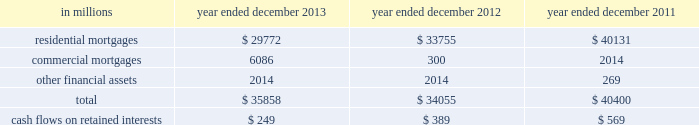Notes to consolidated financial statements note 10 .
Securitization activities the firm securitizes residential and commercial mortgages , corporate bonds , loans and other types of financial assets by selling these assets to securitization vehicles ( e.g. , trusts , corporate entities and limited liability companies ) or through a resecuritization .
The firm acts as underwriter of the beneficial interests that are sold to investors .
The firm 2019s residential mortgage securitizations are substantially all in connection with government agency securitizations .
Beneficial interests issued by securitization entities are debt or equity securities that give the investors rights to receive all or portions of specified cash inflows to a securitization vehicle and include senior and subordinated interests in principal , interest and/or other cash inflows .
The proceeds from the sale of beneficial interests are used to pay the transferor for the financial assets sold to the securitization vehicle or to purchase securities which serve as collateral .
The firm accounts for a securitization as a sale when it has relinquished control over the transferred assets .
Prior to securitization , the firm accounts for assets pending transfer at fair value and therefore does not typically recognize significant gains or losses upon the transfer of assets .
Net revenues from underwriting activities are recognized in connection with the sales of the underlying beneficial interests to investors .
For transfers of assets that are not accounted for as sales , the assets remain in 201cfinancial instruments owned , at fair value 201d and the transfer is accounted for as a collateralized financing , with the related interest expense recognized over the life of the transaction .
See notes 9 and 23 for further information about collateralized financings and interest expense , respectively .
The firm generally receives cash in exchange for the transferred assets but may also have continuing involvement with transferred assets , including ownership of beneficial interests in securitized financial assets , primarily in the form of senior or subordinated securities .
The firm may also purchase senior or subordinated securities issued by securitization vehicles ( which are typically vies ) in connection with secondary market-making activities .
The primary risks included in beneficial interests and other interests from the firm 2019s continuing involvement with securitization vehicles are the performance of the underlying collateral , the position of the firm 2019s investment in the capital structure of the securitization vehicle and the market yield for the security .
These interests are accounted for at fair value and are included in 201cfinancial instruments owned , at fair value 201d and are generally classified in level 2 of the fair value hierarchy .
See notes 5 through 8 for further information about fair value measurements .
The table below presents the amount of financial assets securitized and the cash flows received on retained interests in securitization entities in which the firm had continuing involvement. .
Goldman sachs 2013 annual report 165 .
What percent of financial assets securitized in 2012 were residential mortgages? 
Computations: (33755 / 34055)
Answer: 0.99119. 